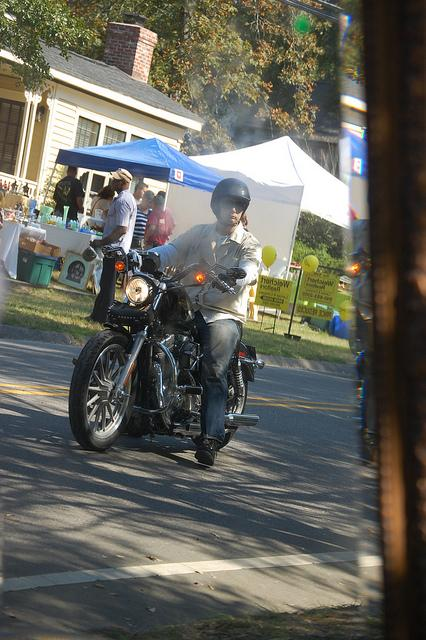What real estate structure is this type of sale often named after? garage 